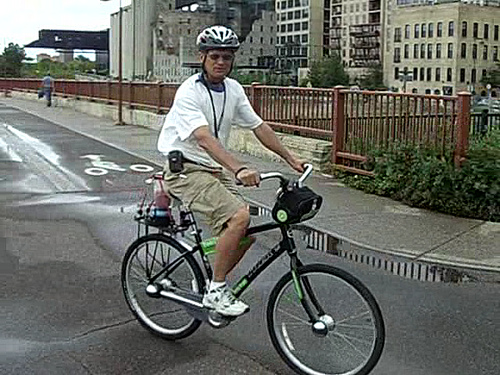Is there anything noticeable about the bicycle itself? The bicycle has a modern design featuring straight lines and appears to be well-maintained. It's equipped with a rear rack, suggesting the rider could use the bike for commuting or carrying items. Moreover, the bike has a prominent chain guard, which helps in keeping the rider's clothing clean and getting caught in the chain. 